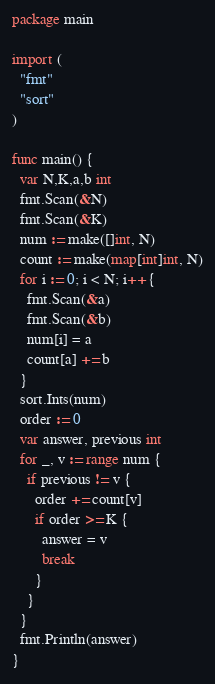<code> <loc_0><loc_0><loc_500><loc_500><_Go_>package main

import (
  "fmt"
  "sort"
)

func main() {
  var N,K,a,b int
  fmt.Scan(&N)
  fmt.Scan(&K)
  num := make([]int, N)
  count := make(map[int]int, N)
  for i := 0; i < N; i++ {
    fmt.Scan(&a)
    fmt.Scan(&b)
    num[i] = a
    count[a] += b
  }
  sort.Ints(num)
  order := 0
  var answer, previous int
  for _, v := range num {
    if previous != v {
      order += count[v]
      if order >= K {
        answer = v
        break
      }
    }
  }
  fmt.Println(answer)
}</code> 